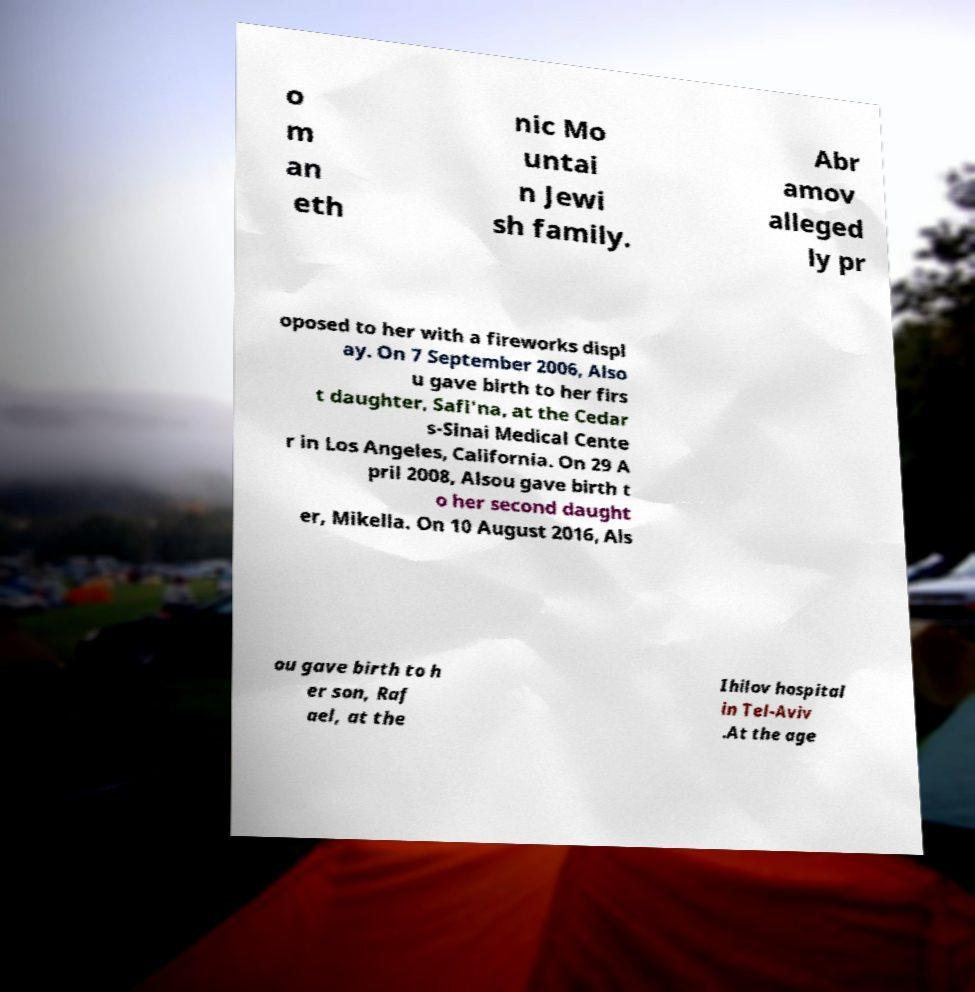I need the written content from this picture converted into text. Can you do that? o m an eth nic Mo untai n Jewi sh family. Abr amov alleged ly pr oposed to her with a fireworks displ ay. On 7 September 2006, Also u gave birth to her firs t daughter, Safi'na, at the Cedar s-Sinai Medical Cente r in Los Angeles, California. On 29 A pril 2008, Alsou gave birth t o her second daught er, Mikella. On 10 August 2016, Als ou gave birth to h er son, Raf ael, at the Ihilov hospital in Tel-Aviv .At the age 